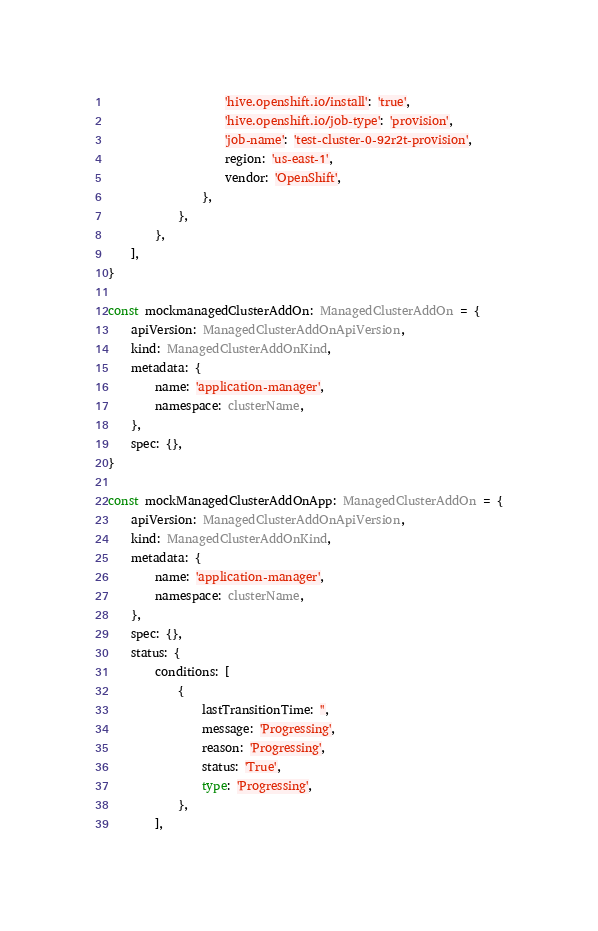Convert code to text. <code><loc_0><loc_0><loc_500><loc_500><_TypeScript_>                    'hive.openshift.io/install': 'true',
                    'hive.openshift.io/job-type': 'provision',
                    'job-name': 'test-cluster-0-92r2t-provision',
                    region: 'us-east-1',
                    vendor: 'OpenShift',
                },
            },
        },
    ],
}

const mockmanagedClusterAddOn: ManagedClusterAddOn = {
    apiVersion: ManagedClusterAddOnApiVersion,
    kind: ManagedClusterAddOnKind,
    metadata: {
        name: 'application-manager',
        namespace: clusterName,
    },
    spec: {},
}

const mockManagedClusterAddOnApp: ManagedClusterAddOn = {
    apiVersion: ManagedClusterAddOnApiVersion,
    kind: ManagedClusterAddOnKind,
    metadata: {
        name: 'application-manager',
        namespace: clusterName,
    },
    spec: {},
    status: {
        conditions: [
            {
                lastTransitionTime: '',
                message: 'Progressing',
                reason: 'Progressing',
                status: 'True',
                type: 'Progressing',
            },
        ],</code> 